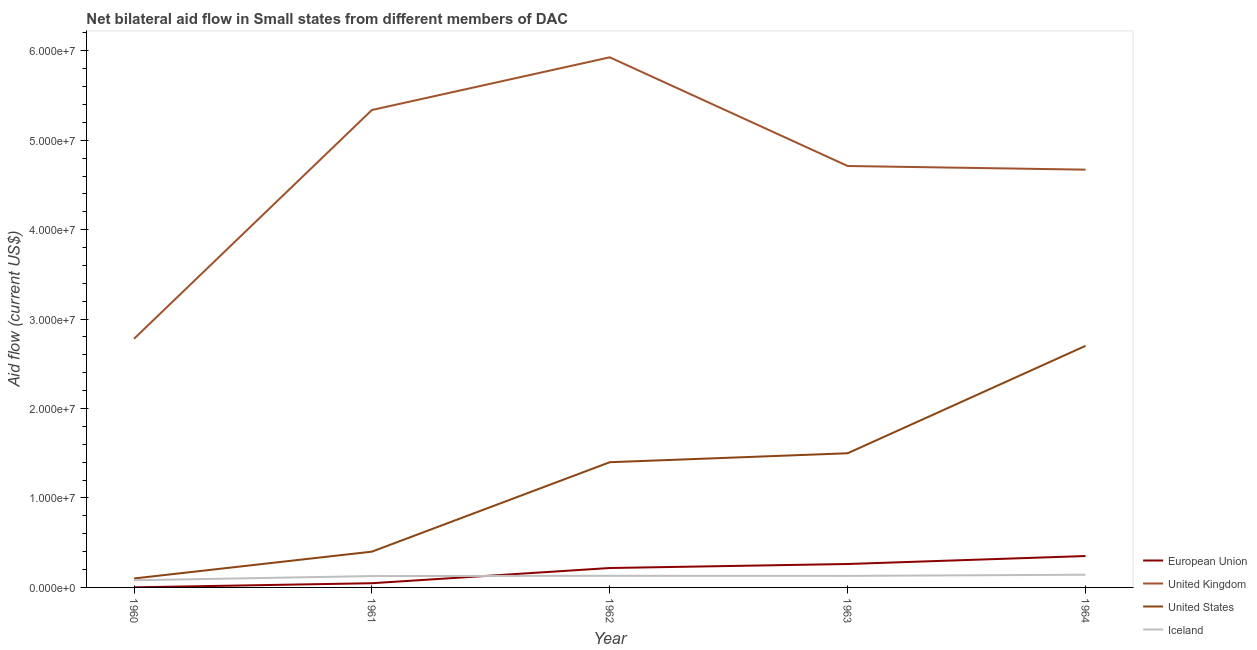How many different coloured lines are there?
Offer a terse response. 4. Is the number of lines equal to the number of legend labels?
Your response must be concise. Yes. What is the amount of aid given by iceland in 1960?
Offer a terse response. 8.00e+05. Across all years, what is the maximum amount of aid given by iceland?
Offer a very short reply. 1.42e+06. Across all years, what is the minimum amount of aid given by uk?
Provide a short and direct response. 2.78e+07. In which year was the amount of aid given by iceland maximum?
Offer a terse response. 1964. What is the total amount of aid given by us in the graph?
Make the answer very short. 6.10e+07. What is the difference between the amount of aid given by us in 1962 and that in 1963?
Give a very brief answer. -1.00e+06. What is the difference between the amount of aid given by eu in 1962 and the amount of aid given by us in 1963?
Make the answer very short. -1.28e+07. What is the average amount of aid given by iceland per year?
Make the answer very short. 1.22e+06. In the year 1963, what is the difference between the amount of aid given by us and amount of aid given by eu?
Provide a succinct answer. 1.24e+07. What is the ratio of the amount of aid given by us in 1961 to that in 1963?
Your answer should be very brief. 0.27. Is the difference between the amount of aid given by eu in 1960 and 1962 greater than the difference between the amount of aid given by uk in 1960 and 1962?
Ensure brevity in your answer.  Yes. What is the difference between the highest and the second highest amount of aid given by eu?
Provide a succinct answer. 8.90e+05. What is the difference between the highest and the lowest amount of aid given by iceland?
Your answer should be compact. 6.20e+05. In how many years, is the amount of aid given by us greater than the average amount of aid given by us taken over all years?
Make the answer very short. 3. Is the sum of the amount of aid given by uk in 1961 and 1964 greater than the maximum amount of aid given by eu across all years?
Your answer should be very brief. Yes. Is it the case that in every year, the sum of the amount of aid given by us and amount of aid given by uk is greater than the sum of amount of aid given by eu and amount of aid given by iceland?
Keep it short and to the point. No. Does the amount of aid given by uk monotonically increase over the years?
Make the answer very short. No. Is the amount of aid given by us strictly greater than the amount of aid given by eu over the years?
Make the answer very short. Yes. Is the amount of aid given by us strictly less than the amount of aid given by uk over the years?
Offer a terse response. Yes. How many lines are there?
Offer a very short reply. 4. How many years are there in the graph?
Give a very brief answer. 5. Are the values on the major ticks of Y-axis written in scientific E-notation?
Offer a terse response. Yes. Where does the legend appear in the graph?
Give a very brief answer. Bottom right. How are the legend labels stacked?
Provide a succinct answer. Vertical. What is the title of the graph?
Offer a terse response. Net bilateral aid flow in Small states from different members of DAC. Does "Salary of employees" appear as one of the legend labels in the graph?
Offer a very short reply. No. What is the label or title of the X-axis?
Provide a succinct answer. Year. What is the Aid flow (current US$) of United Kingdom in 1960?
Make the answer very short. 2.78e+07. What is the Aid flow (current US$) of United States in 1960?
Provide a short and direct response. 1.00e+06. What is the Aid flow (current US$) of European Union in 1961?
Offer a terse response. 4.70e+05. What is the Aid flow (current US$) in United Kingdom in 1961?
Keep it short and to the point. 5.34e+07. What is the Aid flow (current US$) of Iceland in 1961?
Your answer should be compact. 1.27e+06. What is the Aid flow (current US$) in European Union in 1962?
Give a very brief answer. 2.17e+06. What is the Aid flow (current US$) in United Kingdom in 1962?
Provide a succinct answer. 5.93e+07. What is the Aid flow (current US$) in United States in 1962?
Offer a very short reply. 1.40e+07. What is the Aid flow (current US$) in Iceland in 1962?
Offer a very short reply. 1.30e+06. What is the Aid flow (current US$) in European Union in 1963?
Offer a very short reply. 2.62e+06. What is the Aid flow (current US$) in United Kingdom in 1963?
Give a very brief answer. 4.71e+07. What is the Aid flow (current US$) of United States in 1963?
Provide a short and direct response. 1.50e+07. What is the Aid flow (current US$) of Iceland in 1963?
Offer a terse response. 1.29e+06. What is the Aid flow (current US$) in European Union in 1964?
Your answer should be very brief. 3.51e+06. What is the Aid flow (current US$) in United Kingdom in 1964?
Ensure brevity in your answer.  4.67e+07. What is the Aid flow (current US$) in United States in 1964?
Provide a short and direct response. 2.70e+07. What is the Aid flow (current US$) in Iceland in 1964?
Ensure brevity in your answer.  1.42e+06. Across all years, what is the maximum Aid flow (current US$) in European Union?
Provide a short and direct response. 3.51e+06. Across all years, what is the maximum Aid flow (current US$) of United Kingdom?
Offer a very short reply. 5.93e+07. Across all years, what is the maximum Aid flow (current US$) of United States?
Your response must be concise. 2.70e+07. Across all years, what is the maximum Aid flow (current US$) of Iceland?
Keep it short and to the point. 1.42e+06. Across all years, what is the minimum Aid flow (current US$) of United Kingdom?
Provide a short and direct response. 2.78e+07. Across all years, what is the minimum Aid flow (current US$) in Iceland?
Your answer should be compact. 8.00e+05. What is the total Aid flow (current US$) of European Union in the graph?
Keep it short and to the point. 8.78e+06. What is the total Aid flow (current US$) of United Kingdom in the graph?
Your answer should be compact. 2.34e+08. What is the total Aid flow (current US$) of United States in the graph?
Your answer should be compact. 6.10e+07. What is the total Aid flow (current US$) in Iceland in the graph?
Provide a short and direct response. 6.08e+06. What is the difference between the Aid flow (current US$) in European Union in 1960 and that in 1961?
Your response must be concise. -4.60e+05. What is the difference between the Aid flow (current US$) in United Kingdom in 1960 and that in 1961?
Give a very brief answer. -2.56e+07. What is the difference between the Aid flow (current US$) in United States in 1960 and that in 1961?
Your answer should be compact. -3.00e+06. What is the difference between the Aid flow (current US$) of Iceland in 1960 and that in 1961?
Offer a terse response. -4.70e+05. What is the difference between the Aid flow (current US$) in European Union in 1960 and that in 1962?
Keep it short and to the point. -2.16e+06. What is the difference between the Aid flow (current US$) in United Kingdom in 1960 and that in 1962?
Ensure brevity in your answer.  -3.15e+07. What is the difference between the Aid flow (current US$) of United States in 1960 and that in 1962?
Your answer should be very brief. -1.30e+07. What is the difference between the Aid flow (current US$) of Iceland in 1960 and that in 1962?
Keep it short and to the point. -5.00e+05. What is the difference between the Aid flow (current US$) in European Union in 1960 and that in 1963?
Give a very brief answer. -2.61e+06. What is the difference between the Aid flow (current US$) in United Kingdom in 1960 and that in 1963?
Your answer should be very brief. -1.93e+07. What is the difference between the Aid flow (current US$) of United States in 1960 and that in 1963?
Offer a very short reply. -1.40e+07. What is the difference between the Aid flow (current US$) of Iceland in 1960 and that in 1963?
Make the answer very short. -4.90e+05. What is the difference between the Aid flow (current US$) of European Union in 1960 and that in 1964?
Give a very brief answer. -3.50e+06. What is the difference between the Aid flow (current US$) in United Kingdom in 1960 and that in 1964?
Your response must be concise. -1.89e+07. What is the difference between the Aid flow (current US$) in United States in 1960 and that in 1964?
Offer a very short reply. -2.60e+07. What is the difference between the Aid flow (current US$) in Iceland in 1960 and that in 1964?
Provide a short and direct response. -6.20e+05. What is the difference between the Aid flow (current US$) of European Union in 1961 and that in 1962?
Ensure brevity in your answer.  -1.70e+06. What is the difference between the Aid flow (current US$) of United Kingdom in 1961 and that in 1962?
Give a very brief answer. -5.89e+06. What is the difference between the Aid flow (current US$) in United States in 1961 and that in 1962?
Your answer should be very brief. -1.00e+07. What is the difference between the Aid flow (current US$) of Iceland in 1961 and that in 1962?
Offer a very short reply. -3.00e+04. What is the difference between the Aid flow (current US$) of European Union in 1961 and that in 1963?
Your answer should be very brief. -2.15e+06. What is the difference between the Aid flow (current US$) of United Kingdom in 1961 and that in 1963?
Your answer should be very brief. 6.26e+06. What is the difference between the Aid flow (current US$) of United States in 1961 and that in 1963?
Your answer should be very brief. -1.10e+07. What is the difference between the Aid flow (current US$) in European Union in 1961 and that in 1964?
Your response must be concise. -3.04e+06. What is the difference between the Aid flow (current US$) in United Kingdom in 1961 and that in 1964?
Ensure brevity in your answer.  6.67e+06. What is the difference between the Aid flow (current US$) of United States in 1961 and that in 1964?
Your response must be concise. -2.30e+07. What is the difference between the Aid flow (current US$) in European Union in 1962 and that in 1963?
Ensure brevity in your answer.  -4.50e+05. What is the difference between the Aid flow (current US$) of United Kingdom in 1962 and that in 1963?
Keep it short and to the point. 1.22e+07. What is the difference between the Aid flow (current US$) of United States in 1962 and that in 1963?
Keep it short and to the point. -1.00e+06. What is the difference between the Aid flow (current US$) of European Union in 1962 and that in 1964?
Provide a short and direct response. -1.34e+06. What is the difference between the Aid flow (current US$) in United Kingdom in 1962 and that in 1964?
Provide a succinct answer. 1.26e+07. What is the difference between the Aid flow (current US$) in United States in 1962 and that in 1964?
Offer a very short reply. -1.30e+07. What is the difference between the Aid flow (current US$) of European Union in 1963 and that in 1964?
Keep it short and to the point. -8.90e+05. What is the difference between the Aid flow (current US$) in United Kingdom in 1963 and that in 1964?
Your answer should be very brief. 4.10e+05. What is the difference between the Aid flow (current US$) in United States in 1963 and that in 1964?
Provide a succinct answer. -1.20e+07. What is the difference between the Aid flow (current US$) of European Union in 1960 and the Aid flow (current US$) of United Kingdom in 1961?
Provide a succinct answer. -5.34e+07. What is the difference between the Aid flow (current US$) in European Union in 1960 and the Aid flow (current US$) in United States in 1961?
Keep it short and to the point. -3.99e+06. What is the difference between the Aid flow (current US$) of European Union in 1960 and the Aid flow (current US$) of Iceland in 1961?
Provide a short and direct response. -1.26e+06. What is the difference between the Aid flow (current US$) of United Kingdom in 1960 and the Aid flow (current US$) of United States in 1961?
Your response must be concise. 2.38e+07. What is the difference between the Aid flow (current US$) in United Kingdom in 1960 and the Aid flow (current US$) in Iceland in 1961?
Offer a terse response. 2.65e+07. What is the difference between the Aid flow (current US$) of European Union in 1960 and the Aid flow (current US$) of United Kingdom in 1962?
Your response must be concise. -5.93e+07. What is the difference between the Aid flow (current US$) in European Union in 1960 and the Aid flow (current US$) in United States in 1962?
Make the answer very short. -1.40e+07. What is the difference between the Aid flow (current US$) in European Union in 1960 and the Aid flow (current US$) in Iceland in 1962?
Provide a succinct answer. -1.29e+06. What is the difference between the Aid flow (current US$) of United Kingdom in 1960 and the Aid flow (current US$) of United States in 1962?
Give a very brief answer. 1.38e+07. What is the difference between the Aid flow (current US$) of United Kingdom in 1960 and the Aid flow (current US$) of Iceland in 1962?
Provide a succinct answer. 2.65e+07. What is the difference between the Aid flow (current US$) of European Union in 1960 and the Aid flow (current US$) of United Kingdom in 1963?
Ensure brevity in your answer.  -4.71e+07. What is the difference between the Aid flow (current US$) of European Union in 1960 and the Aid flow (current US$) of United States in 1963?
Provide a short and direct response. -1.50e+07. What is the difference between the Aid flow (current US$) in European Union in 1960 and the Aid flow (current US$) in Iceland in 1963?
Offer a very short reply. -1.28e+06. What is the difference between the Aid flow (current US$) of United Kingdom in 1960 and the Aid flow (current US$) of United States in 1963?
Give a very brief answer. 1.28e+07. What is the difference between the Aid flow (current US$) of United Kingdom in 1960 and the Aid flow (current US$) of Iceland in 1963?
Provide a succinct answer. 2.65e+07. What is the difference between the Aid flow (current US$) of European Union in 1960 and the Aid flow (current US$) of United Kingdom in 1964?
Offer a terse response. -4.67e+07. What is the difference between the Aid flow (current US$) in European Union in 1960 and the Aid flow (current US$) in United States in 1964?
Your answer should be very brief. -2.70e+07. What is the difference between the Aid flow (current US$) of European Union in 1960 and the Aid flow (current US$) of Iceland in 1964?
Your response must be concise. -1.41e+06. What is the difference between the Aid flow (current US$) of United Kingdom in 1960 and the Aid flow (current US$) of United States in 1964?
Provide a short and direct response. 7.90e+05. What is the difference between the Aid flow (current US$) of United Kingdom in 1960 and the Aid flow (current US$) of Iceland in 1964?
Your answer should be very brief. 2.64e+07. What is the difference between the Aid flow (current US$) in United States in 1960 and the Aid flow (current US$) in Iceland in 1964?
Make the answer very short. -4.20e+05. What is the difference between the Aid flow (current US$) of European Union in 1961 and the Aid flow (current US$) of United Kingdom in 1962?
Ensure brevity in your answer.  -5.88e+07. What is the difference between the Aid flow (current US$) of European Union in 1961 and the Aid flow (current US$) of United States in 1962?
Ensure brevity in your answer.  -1.35e+07. What is the difference between the Aid flow (current US$) of European Union in 1961 and the Aid flow (current US$) of Iceland in 1962?
Give a very brief answer. -8.30e+05. What is the difference between the Aid flow (current US$) in United Kingdom in 1961 and the Aid flow (current US$) in United States in 1962?
Your answer should be compact. 3.94e+07. What is the difference between the Aid flow (current US$) in United Kingdom in 1961 and the Aid flow (current US$) in Iceland in 1962?
Your answer should be compact. 5.21e+07. What is the difference between the Aid flow (current US$) in United States in 1961 and the Aid flow (current US$) in Iceland in 1962?
Offer a very short reply. 2.70e+06. What is the difference between the Aid flow (current US$) in European Union in 1961 and the Aid flow (current US$) in United Kingdom in 1963?
Ensure brevity in your answer.  -4.66e+07. What is the difference between the Aid flow (current US$) in European Union in 1961 and the Aid flow (current US$) in United States in 1963?
Give a very brief answer. -1.45e+07. What is the difference between the Aid flow (current US$) in European Union in 1961 and the Aid flow (current US$) in Iceland in 1963?
Provide a short and direct response. -8.20e+05. What is the difference between the Aid flow (current US$) of United Kingdom in 1961 and the Aid flow (current US$) of United States in 1963?
Offer a terse response. 3.84e+07. What is the difference between the Aid flow (current US$) in United Kingdom in 1961 and the Aid flow (current US$) in Iceland in 1963?
Your response must be concise. 5.21e+07. What is the difference between the Aid flow (current US$) in United States in 1961 and the Aid flow (current US$) in Iceland in 1963?
Your answer should be very brief. 2.71e+06. What is the difference between the Aid flow (current US$) in European Union in 1961 and the Aid flow (current US$) in United Kingdom in 1964?
Keep it short and to the point. -4.62e+07. What is the difference between the Aid flow (current US$) in European Union in 1961 and the Aid flow (current US$) in United States in 1964?
Offer a terse response. -2.65e+07. What is the difference between the Aid flow (current US$) in European Union in 1961 and the Aid flow (current US$) in Iceland in 1964?
Your response must be concise. -9.50e+05. What is the difference between the Aid flow (current US$) in United Kingdom in 1961 and the Aid flow (current US$) in United States in 1964?
Your answer should be very brief. 2.64e+07. What is the difference between the Aid flow (current US$) of United Kingdom in 1961 and the Aid flow (current US$) of Iceland in 1964?
Provide a short and direct response. 5.20e+07. What is the difference between the Aid flow (current US$) of United States in 1961 and the Aid flow (current US$) of Iceland in 1964?
Provide a short and direct response. 2.58e+06. What is the difference between the Aid flow (current US$) in European Union in 1962 and the Aid flow (current US$) in United Kingdom in 1963?
Your answer should be compact. -4.50e+07. What is the difference between the Aid flow (current US$) in European Union in 1962 and the Aid flow (current US$) in United States in 1963?
Your answer should be compact. -1.28e+07. What is the difference between the Aid flow (current US$) of European Union in 1962 and the Aid flow (current US$) of Iceland in 1963?
Ensure brevity in your answer.  8.80e+05. What is the difference between the Aid flow (current US$) of United Kingdom in 1962 and the Aid flow (current US$) of United States in 1963?
Your answer should be compact. 4.43e+07. What is the difference between the Aid flow (current US$) in United Kingdom in 1962 and the Aid flow (current US$) in Iceland in 1963?
Ensure brevity in your answer.  5.80e+07. What is the difference between the Aid flow (current US$) of United States in 1962 and the Aid flow (current US$) of Iceland in 1963?
Offer a very short reply. 1.27e+07. What is the difference between the Aid flow (current US$) in European Union in 1962 and the Aid flow (current US$) in United Kingdom in 1964?
Give a very brief answer. -4.45e+07. What is the difference between the Aid flow (current US$) of European Union in 1962 and the Aid flow (current US$) of United States in 1964?
Make the answer very short. -2.48e+07. What is the difference between the Aid flow (current US$) of European Union in 1962 and the Aid flow (current US$) of Iceland in 1964?
Offer a terse response. 7.50e+05. What is the difference between the Aid flow (current US$) in United Kingdom in 1962 and the Aid flow (current US$) in United States in 1964?
Provide a succinct answer. 3.23e+07. What is the difference between the Aid flow (current US$) in United Kingdom in 1962 and the Aid flow (current US$) in Iceland in 1964?
Ensure brevity in your answer.  5.78e+07. What is the difference between the Aid flow (current US$) in United States in 1962 and the Aid flow (current US$) in Iceland in 1964?
Offer a terse response. 1.26e+07. What is the difference between the Aid flow (current US$) of European Union in 1963 and the Aid flow (current US$) of United Kingdom in 1964?
Give a very brief answer. -4.41e+07. What is the difference between the Aid flow (current US$) of European Union in 1963 and the Aid flow (current US$) of United States in 1964?
Provide a short and direct response. -2.44e+07. What is the difference between the Aid flow (current US$) of European Union in 1963 and the Aid flow (current US$) of Iceland in 1964?
Offer a terse response. 1.20e+06. What is the difference between the Aid flow (current US$) in United Kingdom in 1963 and the Aid flow (current US$) in United States in 1964?
Make the answer very short. 2.01e+07. What is the difference between the Aid flow (current US$) in United Kingdom in 1963 and the Aid flow (current US$) in Iceland in 1964?
Make the answer very short. 4.57e+07. What is the difference between the Aid flow (current US$) in United States in 1963 and the Aid flow (current US$) in Iceland in 1964?
Your answer should be compact. 1.36e+07. What is the average Aid flow (current US$) of European Union per year?
Your response must be concise. 1.76e+06. What is the average Aid flow (current US$) of United Kingdom per year?
Your answer should be compact. 4.69e+07. What is the average Aid flow (current US$) of United States per year?
Keep it short and to the point. 1.22e+07. What is the average Aid flow (current US$) of Iceland per year?
Provide a short and direct response. 1.22e+06. In the year 1960, what is the difference between the Aid flow (current US$) of European Union and Aid flow (current US$) of United Kingdom?
Make the answer very short. -2.78e+07. In the year 1960, what is the difference between the Aid flow (current US$) of European Union and Aid flow (current US$) of United States?
Offer a terse response. -9.90e+05. In the year 1960, what is the difference between the Aid flow (current US$) of European Union and Aid flow (current US$) of Iceland?
Make the answer very short. -7.90e+05. In the year 1960, what is the difference between the Aid flow (current US$) of United Kingdom and Aid flow (current US$) of United States?
Give a very brief answer. 2.68e+07. In the year 1960, what is the difference between the Aid flow (current US$) in United Kingdom and Aid flow (current US$) in Iceland?
Your response must be concise. 2.70e+07. In the year 1960, what is the difference between the Aid flow (current US$) in United States and Aid flow (current US$) in Iceland?
Offer a terse response. 2.00e+05. In the year 1961, what is the difference between the Aid flow (current US$) of European Union and Aid flow (current US$) of United Kingdom?
Offer a terse response. -5.29e+07. In the year 1961, what is the difference between the Aid flow (current US$) of European Union and Aid flow (current US$) of United States?
Ensure brevity in your answer.  -3.53e+06. In the year 1961, what is the difference between the Aid flow (current US$) of European Union and Aid flow (current US$) of Iceland?
Your answer should be very brief. -8.00e+05. In the year 1961, what is the difference between the Aid flow (current US$) of United Kingdom and Aid flow (current US$) of United States?
Your response must be concise. 4.94e+07. In the year 1961, what is the difference between the Aid flow (current US$) in United Kingdom and Aid flow (current US$) in Iceland?
Ensure brevity in your answer.  5.21e+07. In the year 1961, what is the difference between the Aid flow (current US$) in United States and Aid flow (current US$) in Iceland?
Keep it short and to the point. 2.73e+06. In the year 1962, what is the difference between the Aid flow (current US$) in European Union and Aid flow (current US$) in United Kingdom?
Your answer should be very brief. -5.71e+07. In the year 1962, what is the difference between the Aid flow (current US$) of European Union and Aid flow (current US$) of United States?
Offer a very short reply. -1.18e+07. In the year 1962, what is the difference between the Aid flow (current US$) in European Union and Aid flow (current US$) in Iceland?
Your answer should be very brief. 8.70e+05. In the year 1962, what is the difference between the Aid flow (current US$) in United Kingdom and Aid flow (current US$) in United States?
Ensure brevity in your answer.  4.53e+07. In the year 1962, what is the difference between the Aid flow (current US$) of United Kingdom and Aid flow (current US$) of Iceland?
Provide a short and direct response. 5.80e+07. In the year 1962, what is the difference between the Aid flow (current US$) of United States and Aid flow (current US$) of Iceland?
Provide a short and direct response. 1.27e+07. In the year 1963, what is the difference between the Aid flow (current US$) of European Union and Aid flow (current US$) of United Kingdom?
Ensure brevity in your answer.  -4.45e+07. In the year 1963, what is the difference between the Aid flow (current US$) of European Union and Aid flow (current US$) of United States?
Your answer should be very brief. -1.24e+07. In the year 1963, what is the difference between the Aid flow (current US$) of European Union and Aid flow (current US$) of Iceland?
Give a very brief answer. 1.33e+06. In the year 1963, what is the difference between the Aid flow (current US$) in United Kingdom and Aid flow (current US$) in United States?
Provide a short and direct response. 3.21e+07. In the year 1963, what is the difference between the Aid flow (current US$) of United Kingdom and Aid flow (current US$) of Iceland?
Your response must be concise. 4.58e+07. In the year 1963, what is the difference between the Aid flow (current US$) in United States and Aid flow (current US$) in Iceland?
Provide a short and direct response. 1.37e+07. In the year 1964, what is the difference between the Aid flow (current US$) in European Union and Aid flow (current US$) in United Kingdom?
Provide a short and direct response. -4.32e+07. In the year 1964, what is the difference between the Aid flow (current US$) in European Union and Aid flow (current US$) in United States?
Give a very brief answer. -2.35e+07. In the year 1964, what is the difference between the Aid flow (current US$) in European Union and Aid flow (current US$) in Iceland?
Provide a succinct answer. 2.09e+06. In the year 1964, what is the difference between the Aid flow (current US$) of United Kingdom and Aid flow (current US$) of United States?
Keep it short and to the point. 1.97e+07. In the year 1964, what is the difference between the Aid flow (current US$) of United Kingdom and Aid flow (current US$) of Iceland?
Offer a very short reply. 4.53e+07. In the year 1964, what is the difference between the Aid flow (current US$) of United States and Aid flow (current US$) of Iceland?
Your response must be concise. 2.56e+07. What is the ratio of the Aid flow (current US$) of European Union in 1960 to that in 1961?
Make the answer very short. 0.02. What is the ratio of the Aid flow (current US$) of United Kingdom in 1960 to that in 1961?
Ensure brevity in your answer.  0.52. What is the ratio of the Aid flow (current US$) of United States in 1960 to that in 1961?
Offer a very short reply. 0.25. What is the ratio of the Aid flow (current US$) in Iceland in 1960 to that in 1961?
Offer a very short reply. 0.63. What is the ratio of the Aid flow (current US$) of European Union in 1960 to that in 1962?
Give a very brief answer. 0. What is the ratio of the Aid flow (current US$) in United Kingdom in 1960 to that in 1962?
Offer a very short reply. 0.47. What is the ratio of the Aid flow (current US$) in United States in 1960 to that in 1962?
Your answer should be compact. 0.07. What is the ratio of the Aid flow (current US$) in Iceland in 1960 to that in 1962?
Provide a short and direct response. 0.62. What is the ratio of the Aid flow (current US$) in European Union in 1960 to that in 1963?
Give a very brief answer. 0. What is the ratio of the Aid flow (current US$) of United Kingdom in 1960 to that in 1963?
Provide a short and direct response. 0.59. What is the ratio of the Aid flow (current US$) in United States in 1960 to that in 1963?
Provide a short and direct response. 0.07. What is the ratio of the Aid flow (current US$) of Iceland in 1960 to that in 1963?
Your answer should be very brief. 0.62. What is the ratio of the Aid flow (current US$) of European Union in 1960 to that in 1964?
Provide a short and direct response. 0. What is the ratio of the Aid flow (current US$) of United Kingdom in 1960 to that in 1964?
Keep it short and to the point. 0.6. What is the ratio of the Aid flow (current US$) in United States in 1960 to that in 1964?
Offer a very short reply. 0.04. What is the ratio of the Aid flow (current US$) of Iceland in 1960 to that in 1964?
Make the answer very short. 0.56. What is the ratio of the Aid flow (current US$) in European Union in 1961 to that in 1962?
Give a very brief answer. 0.22. What is the ratio of the Aid flow (current US$) of United Kingdom in 1961 to that in 1962?
Give a very brief answer. 0.9. What is the ratio of the Aid flow (current US$) in United States in 1961 to that in 1962?
Your answer should be compact. 0.29. What is the ratio of the Aid flow (current US$) in Iceland in 1961 to that in 1962?
Provide a short and direct response. 0.98. What is the ratio of the Aid flow (current US$) of European Union in 1961 to that in 1963?
Make the answer very short. 0.18. What is the ratio of the Aid flow (current US$) in United Kingdom in 1961 to that in 1963?
Offer a very short reply. 1.13. What is the ratio of the Aid flow (current US$) in United States in 1961 to that in 1963?
Provide a succinct answer. 0.27. What is the ratio of the Aid flow (current US$) in Iceland in 1961 to that in 1963?
Provide a succinct answer. 0.98. What is the ratio of the Aid flow (current US$) in European Union in 1961 to that in 1964?
Your answer should be very brief. 0.13. What is the ratio of the Aid flow (current US$) of United Kingdom in 1961 to that in 1964?
Provide a succinct answer. 1.14. What is the ratio of the Aid flow (current US$) in United States in 1961 to that in 1964?
Your answer should be compact. 0.15. What is the ratio of the Aid flow (current US$) in Iceland in 1961 to that in 1964?
Ensure brevity in your answer.  0.89. What is the ratio of the Aid flow (current US$) in European Union in 1962 to that in 1963?
Your answer should be very brief. 0.83. What is the ratio of the Aid flow (current US$) of United Kingdom in 1962 to that in 1963?
Your answer should be compact. 1.26. What is the ratio of the Aid flow (current US$) in European Union in 1962 to that in 1964?
Offer a terse response. 0.62. What is the ratio of the Aid flow (current US$) in United Kingdom in 1962 to that in 1964?
Keep it short and to the point. 1.27. What is the ratio of the Aid flow (current US$) in United States in 1962 to that in 1964?
Make the answer very short. 0.52. What is the ratio of the Aid flow (current US$) of Iceland in 1962 to that in 1964?
Your response must be concise. 0.92. What is the ratio of the Aid flow (current US$) of European Union in 1963 to that in 1964?
Give a very brief answer. 0.75. What is the ratio of the Aid flow (current US$) in United Kingdom in 1963 to that in 1964?
Make the answer very short. 1.01. What is the ratio of the Aid flow (current US$) of United States in 1963 to that in 1964?
Your response must be concise. 0.56. What is the ratio of the Aid flow (current US$) in Iceland in 1963 to that in 1964?
Your response must be concise. 0.91. What is the difference between the highest and the second highest Aid flow (current US$) of European Union?
Your answer should be very brief. 8.90e+05. What is the difference between the highest and the second highest Aid flow (current US$) in United Kingdom?
Offer a terse response. 5.89e+06. What is the difference between the highest and the second highest Aid flow (current US$) of United States?
Provide a short and direct response. 1.20e+07. What is the difference between the highest and the second highest Aid flow (current US$) of Iceland?
Keep it short and to the point. 1.20e+05. What is the difference between the highest and the lowest Aid flow (current US$) in European Union?
Your answer should be compact. 3.50e+06. What is the difference between the highest and the lowest Aid flow (current US$) of United Kingdom?
Offer a very short reply. 3.15e+07. What is the difference between the highest and the lowest Aid flow (current US$) of United States?
Ensure brevity in your answer.  2.60e+07. What is the difference between the highest and the lowest Aid flow (current US$) of Iceland?
Offer a terse response. 6.20e+05. 